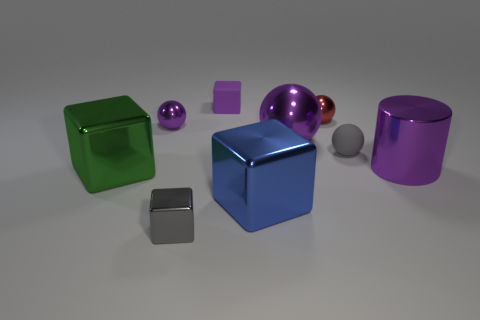Subtract all brown balls. Subtract all red cylinders. How many balls are left? 4 Subtract all blocks. How many objects are left? 5 Subtract 0 yellow blocks. How many objects are left? 9 Subtract all gray balls. Subtract all purple metal objects. How many objects are left? 5 Add 2 tiny purple matte blocks. How many tiny purple matte blocks are left? 3 Add 4 gray metal things. How many gray metal things exist? 5 